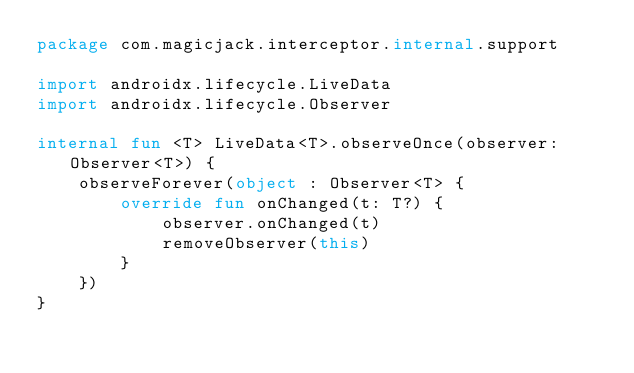Convert code to text. <code><loc_0><loc_0><loc_500><loc_500><_Kotlin_>package com.magicjack.interceptor.internal.support

import androidx.lifecycle.LiveData
import androidx.lifecycle.Observer

internal fun <T> LiveData<T>.observeOnce(observer: Observer<T>) {
    observeForever(object : Observer<T> {
        override fun onChanged(t: T?) {
            observer.onChanged(t)
            removeObserver(this)
        }
    })
}
</code> 